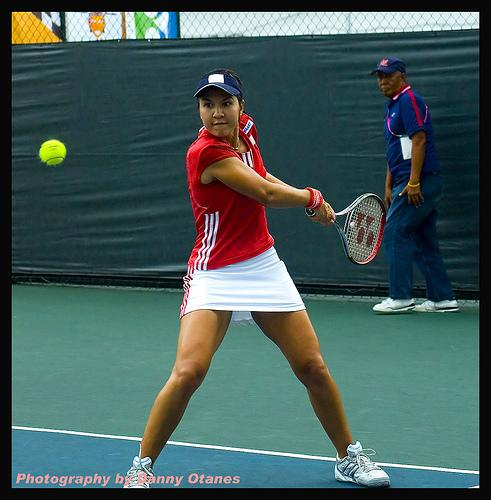The ball used in badminton is made up of what? Please explain your reasoning. wool. Badminton balls have wool. 